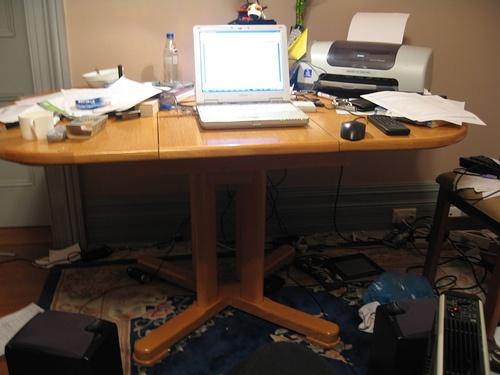Describe the objects in this image and their specific colors. I can see dining table in gray, black, tan, maroon, and brown tones, laptop in gray, white, tan, darkgray, and lightblue tones, chair in gray, black, maroon, and darkgray tones, bottle in gray, darkgray, tan, and lightgray tones, and cup in gray, lightgray, and tan tones in this image. 